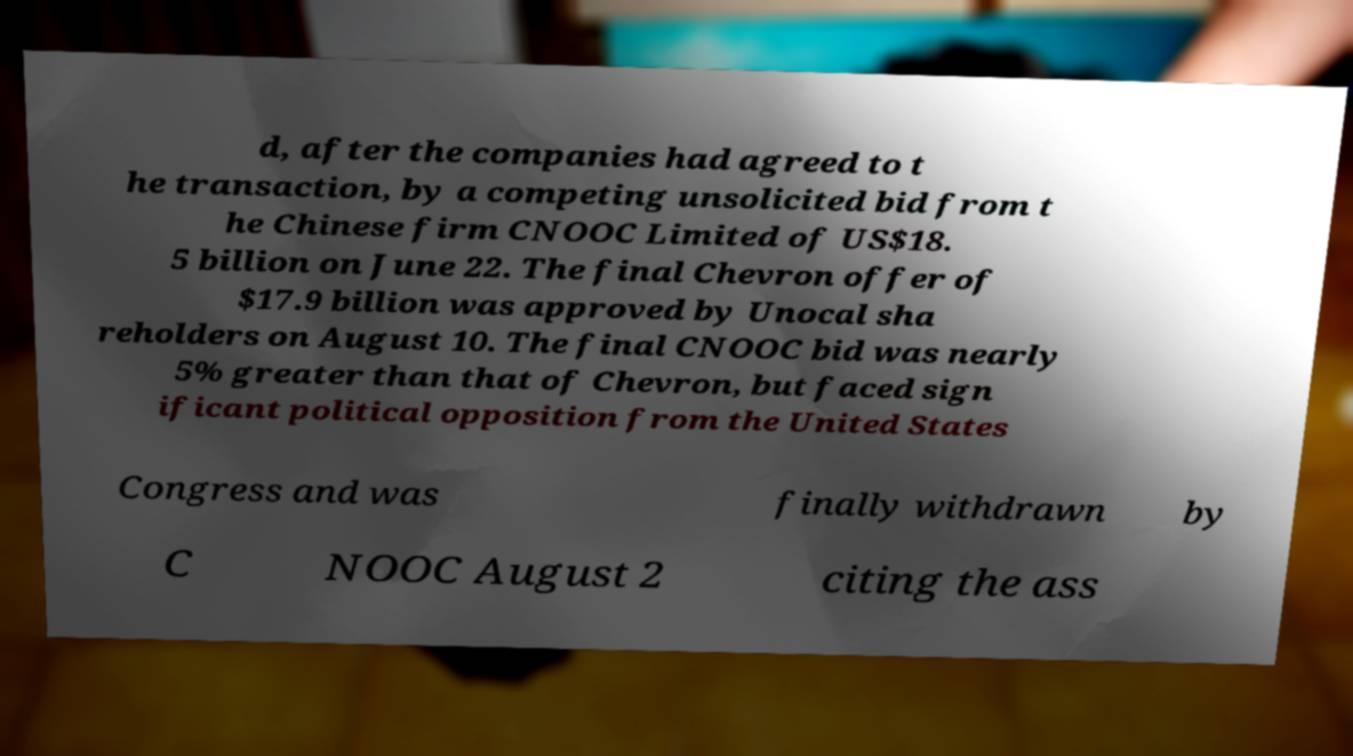Please identify and transcribe the text found in this image. d, after the companies had agreed to t he transaction, by a competing unsolicited bid from t he Chinese firm CNOOC Limited of US$18. 5 billion on June 22. The final Chevron offer of $17.9 billion was approved by Unocal sha reholders on August 10. The final CNOOC bid was nearly 5% greater than that of Chevron, but faced sign ificant political opposition from the United States Congress and was finally withdrawn by C NOOC August 2 citing the ass 